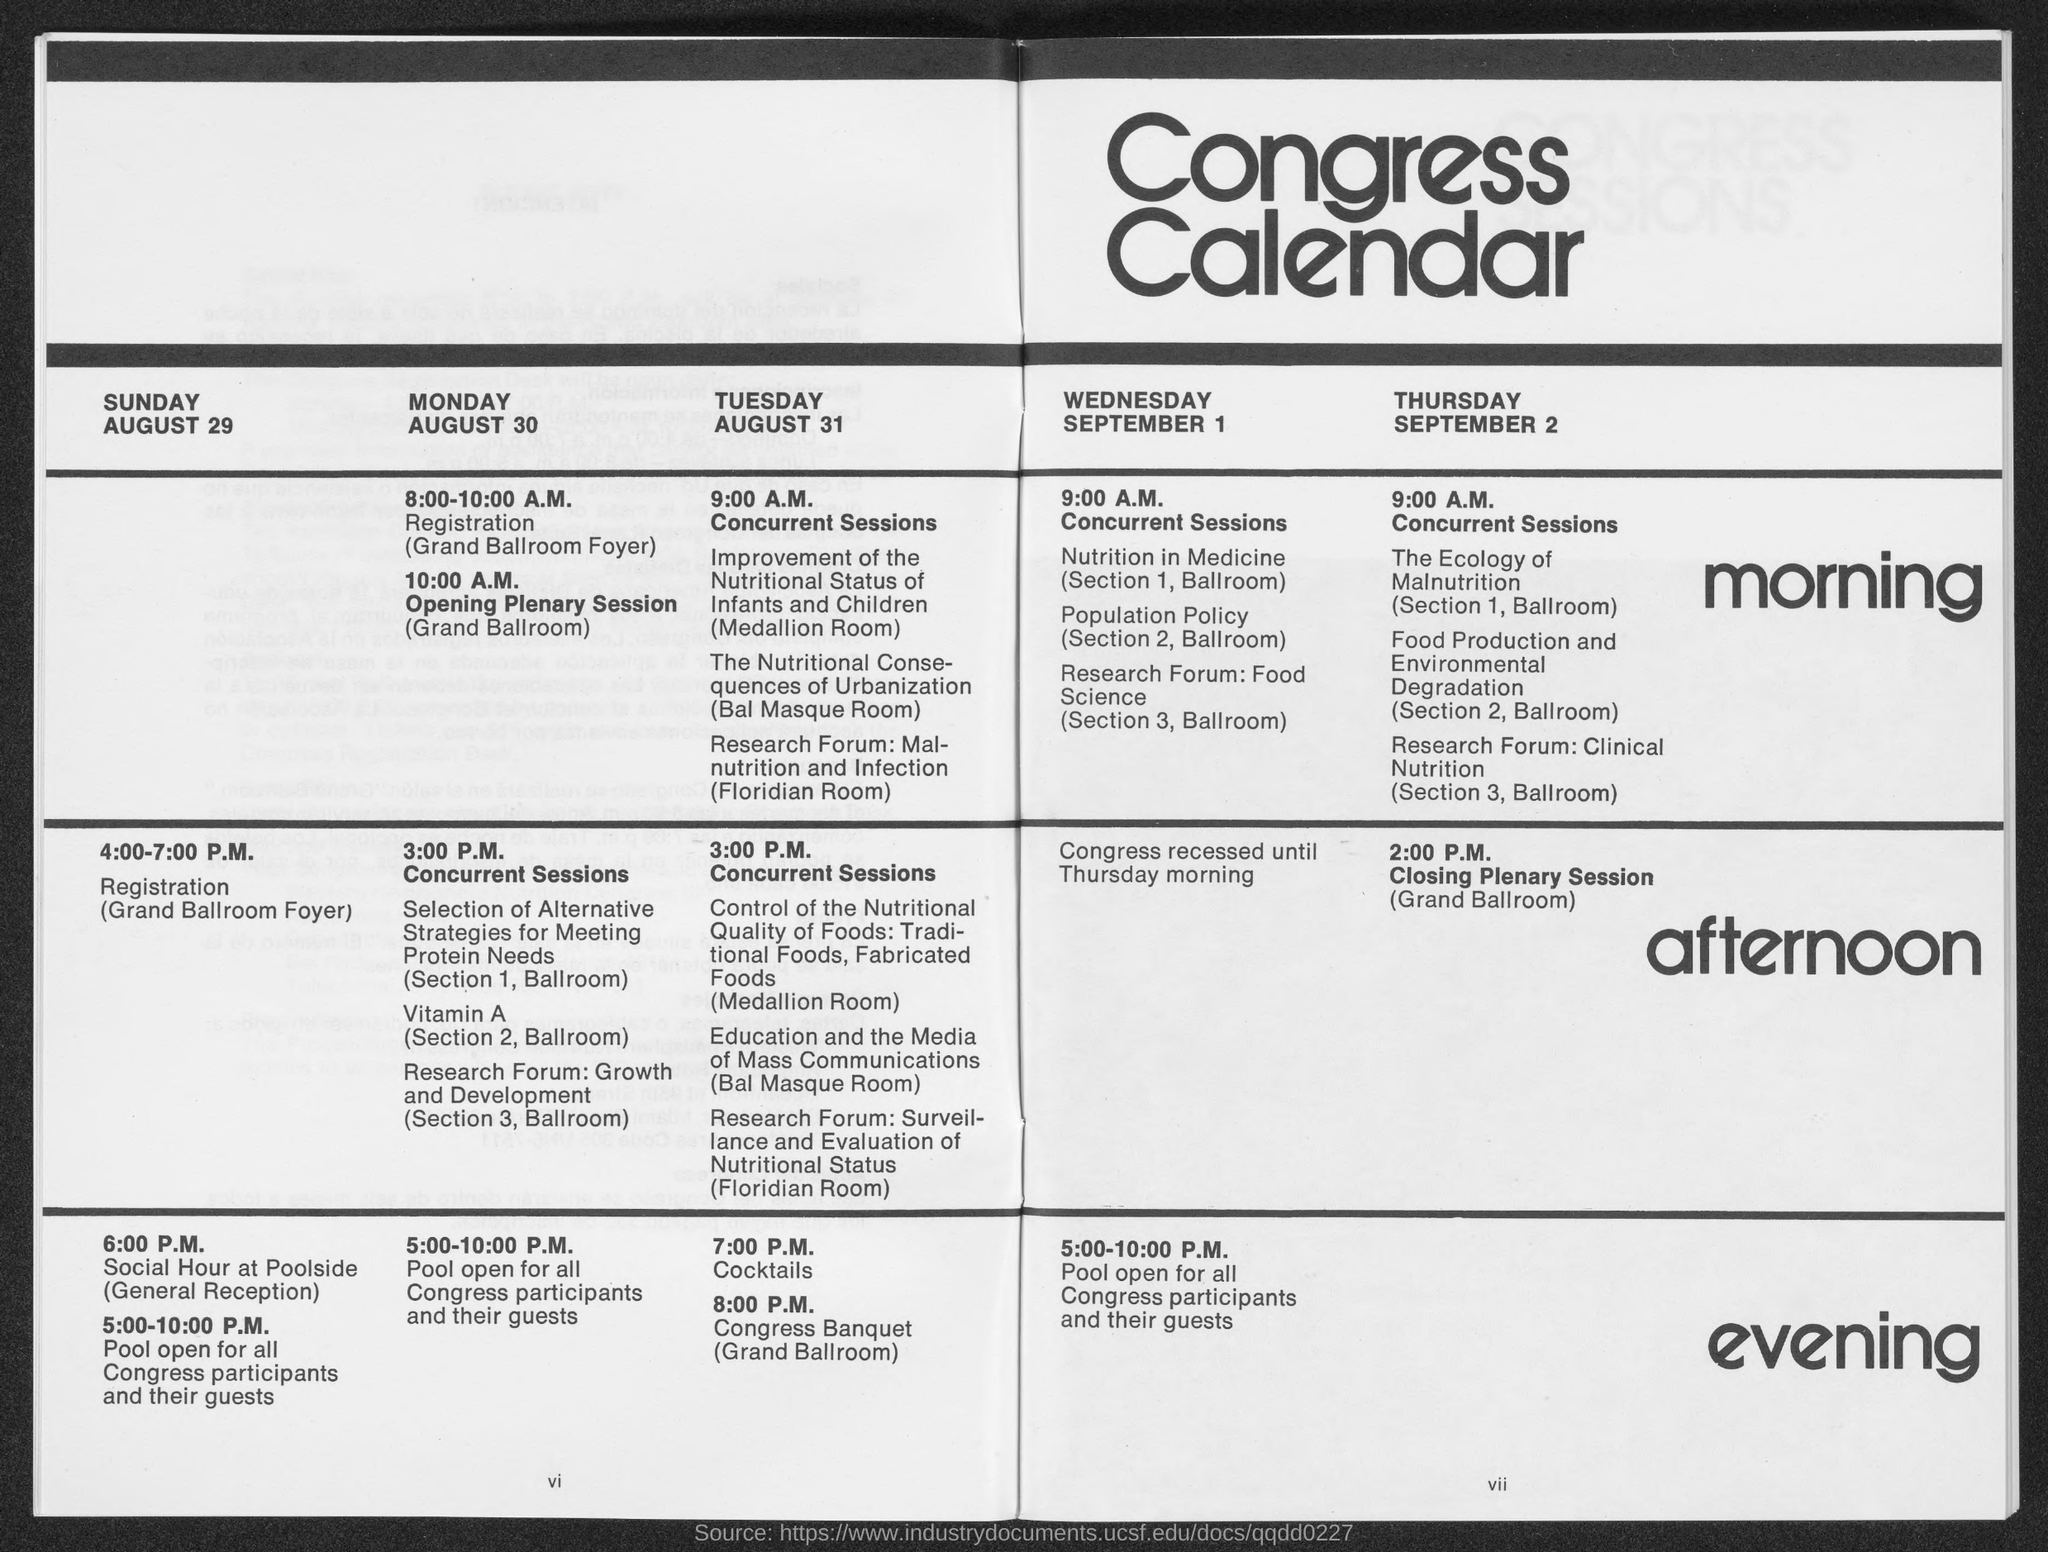Point out several critical features in this image. The registration will begin at 4:00-7:00 P.M. on Sunday. On August 30th, according to the Congress Calendar, it is a Monday. On August 29 according to the Congress Calendar, it is a SUNDAY. The concurrent sessions will be conducted on Thursday at 9:00 A.M. The Congress calendar shows the first date to be August 29th. 